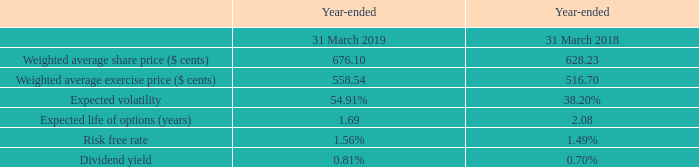Share Options
The fair value of equity-settled share options granted is measured as at the date of grant using a Black-Scholes model, taking into account the terms and conditions upon which the options were granted.
The following table illustrates the weighted average inputs into the Black-Scholes model in the year:
The weighted average fair value of options granted during the year was $ cents 220.53 (2018: $ cents 185.33).
The expected volatility reflects the assumption that the historical share price volatility is indicative of future trends, which may not necessarily be the actual outcome. An increase in the expected volatility will increase the estimated fair value.
The expected life of the options is based on historical data and is not necessarily indicative of exercise patterns that may occur. The expected life used in the model has been adjusted, based on the Director’s best estimate, taking into account the effects of exercise restrictions, non-transferability and behavioural considerations. An increase in the expected life will increase the estimated fair value.
What assumption is reflected by the expected volatility? Assumption that the historical share price volatility is indicative of future trends, which may not necessarily be the actual outcome. an increase in the expected volatility will increase the estimated fair value. What is the expected life of the options based on? Historical data and is not necessarily indicative of exercise patterns that may occur. the expected life used in the model has been adjusted, based on the director’s best estimate, taking into account the effects of exercise restrictions, non-transferability and behavioural considerations. an increase in the expected life will increase the estimated fair value. For which years are the weighted average inputs into the Black-Scholes model considered?  2019, 2018. In which year was the Weighted average share price larger? 676.10>628.23
Answer: 2019. What was the change in Weighted average share price in 2019 from 2018? 676.10-628.23
Answer: 47.87. What was the percentage change in Weighted average share price in 2019 from 2018?
Answer scale should be: percent. (676.10-628.23)/628.23
Answer: 7.62. 